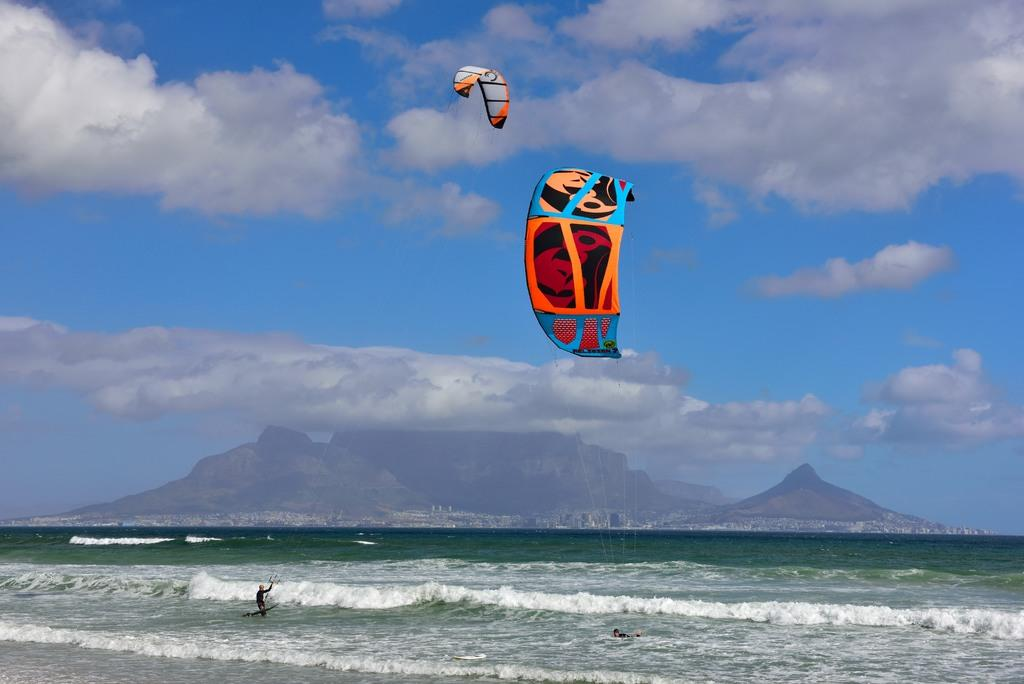How many people are in the image? There are two persons in the image. What are the persons doing in the image? The persons are on the ground and have parachutes. What can be seen in the background of the image? There is an ocean visible in the image, and there is a mountain in the background. What is the condition of the sky in the image? The sky is clear in the image. What type of frog can be seen jumping downtown in the image? There is no frog present in the image, and the image does not depict a downtown area. Is there a jail visible in the image? There is no jail present in the image. 